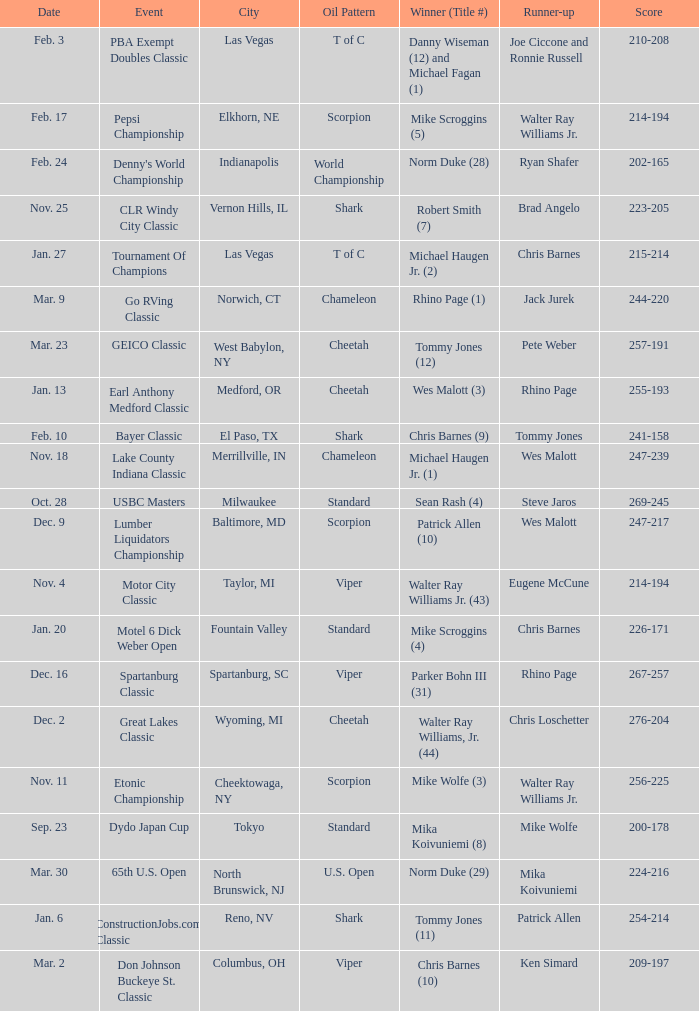Name the Date which has a Oil Pattern of chameleon, and a Event of lake county indiana classic? Nov. 18. 